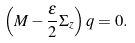<formula> <loc_0><loc_0><loc_500><loc_500>\left ( M - \frac { \epsilon } { 2 } \Sigma _ { z } \right ) q = 0 .</formula> 